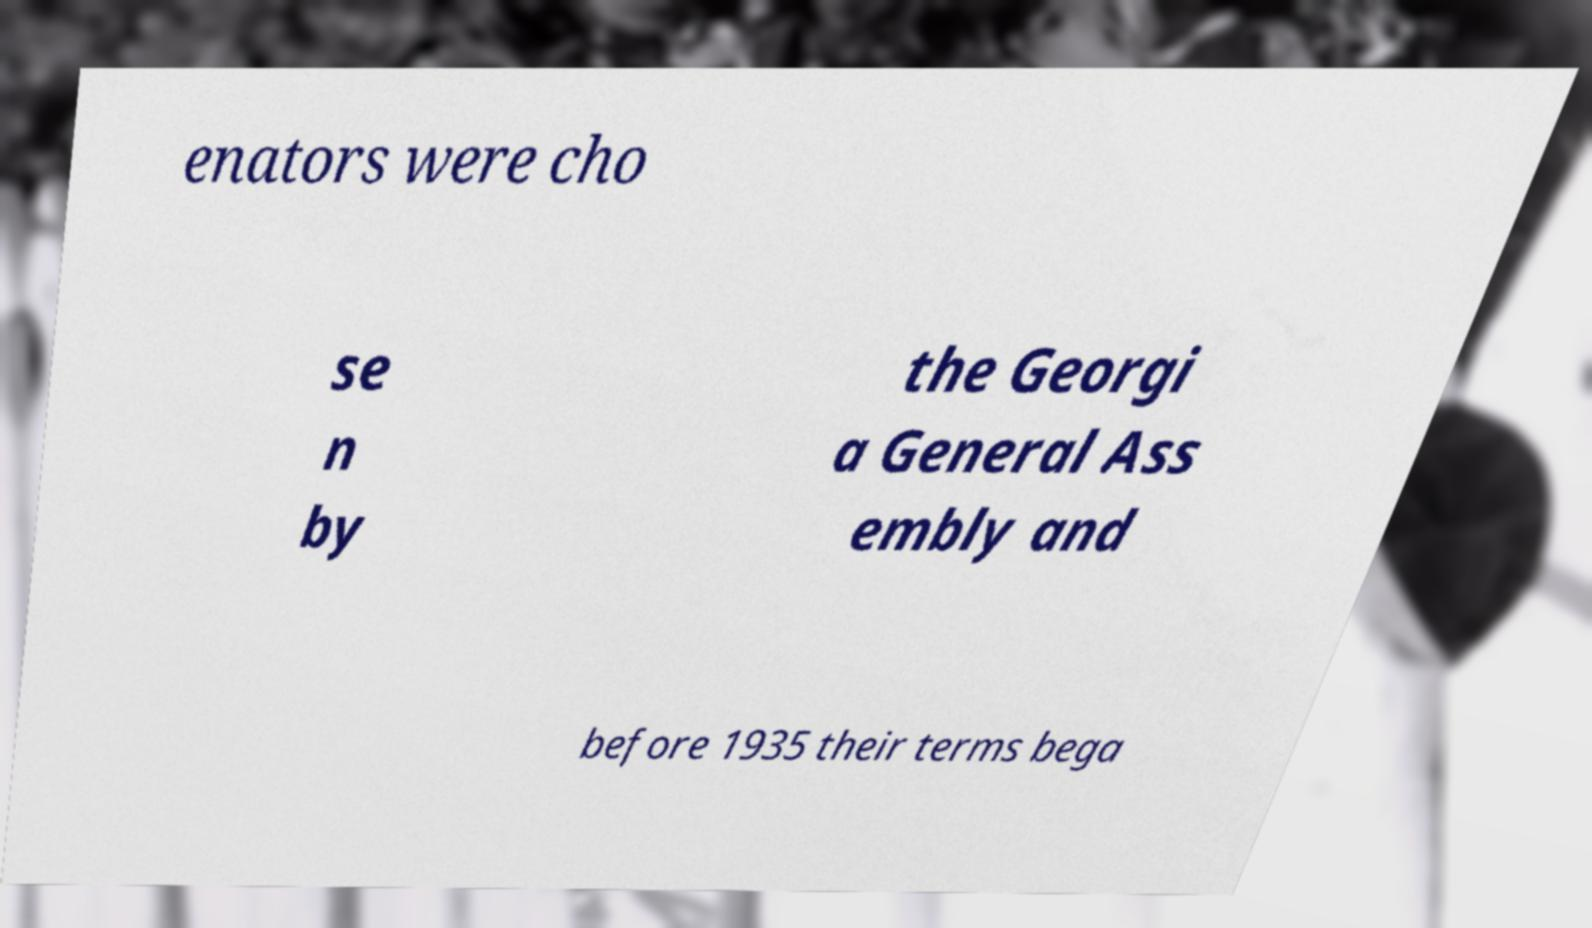I need the written content from this picture converted into text. Can you do that? enators were cho se n by the Georgi a General Ass embly and before 1935 their terms bega 